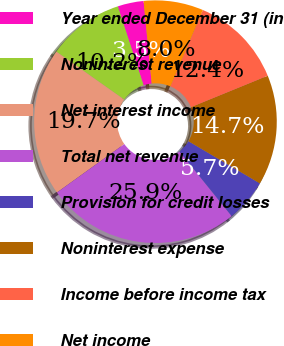Convert chart. <chart><loc_0><loc_0><loc_500><loc_500><pie_chart><fcel>Year ended December 31 (in<fcel>Noninterest revenue<fcel>Net interest income<fcel>Total net revenue<fcel>Provision for credit losses<fcel>Noninterest expense<fcel>Income before income tax<fcel>Net income<nl><fcel>3.46%<fcel>10.19%<fcel>19.71%<fcel>25.88%<fcel>5.7%<fcel>14.67%<fcel>12.43%<fcel>7.95%<nl></chart> 